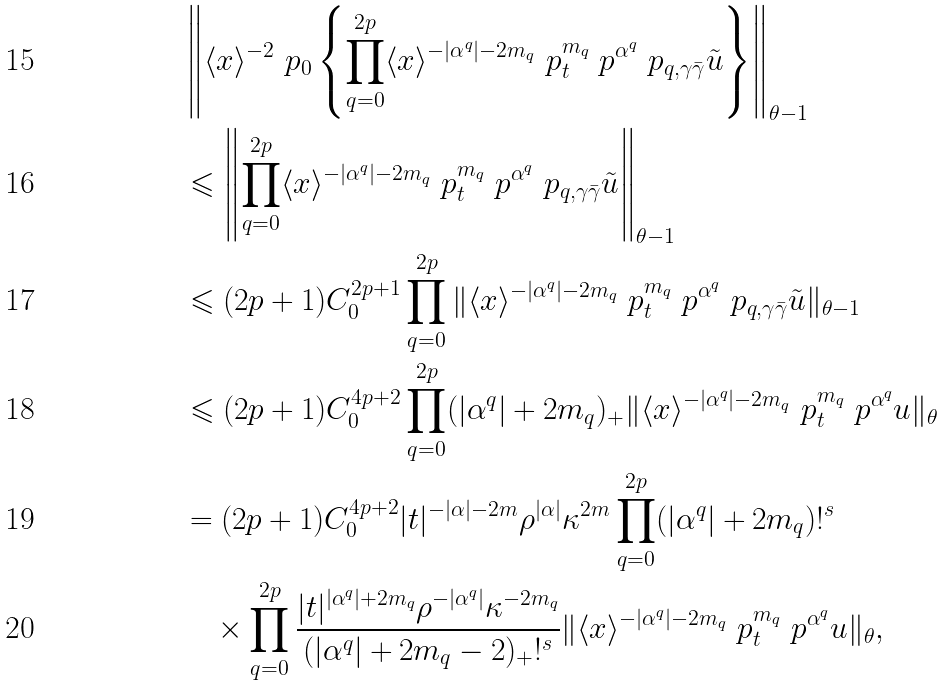Convert formula to latex. <formula><loc_0><loc_0><loc_500><loc_500>& \left \| \langle { x } \rangle ^ { - 2 } \ p _ { 0 } \left \{ \prod _ { q = 0 } ^ { 2 p } \langle { x } \rangle ^ { - | \alpha ^ { q } | - 2 m _ { q } } \ p _ { t } ^ { m _ { q } } \ p ^ { \alpha ^ { q } } \ p _ { q , \gamma \bar { \gamma } } \tilde { u } \right \} \right \| _ { \theta - 1 } \\ & \leqslant \left \| \prod _ { q = 0 } ^ { 2 p } \langle { x } \rangle ^ { - | \alpha ^ { q } | - 2 m _ { q } } \ p _ { t } ^ { m _ { q } } \ p ^ { \alpha ^ { q } } \ p _ { q , \gamma \bar { \gamma } } \tilde { u } \right \| _ { \theta - 1 } \\ & \leqslant ( 2 p + 1 ) C _ { 0 } ^ { 2 p + 1 } \prod _ { q = 0 } ^ { 2 p } \| \langle { x } \rangle ^ { - | \alpha ^ { q } | - 2 m _ { q } } \ p _ { t } ^ { m _ { q } } \ p ^ { \alpha ^ { q } } \ p _ { q , \gamma \bar { \gamma } } \tilde { u } \| _ { \theta - 1 } \\ & \leqslant ( 2 p + 1 ) C _ { 0 } ^ { 4 p + 2 } \prod _ { q = 0 } ^ { 2 p } ( | \alpha ^ { q } | + 2 m _ { q } ) _ { + } \| \langle { x } \rangle ^ { - | \alpha ^ { q } | - 2 m _ { q } } \ p _ { t } ^ { m _ { q } } \ p ^ { \alpha ^ { q } } u \| _ { \theta } \\ & = ( 2 p + 1 ) C _ { 0 } ^ { 4 p + 2 } | { t } | ^ { - | \alpha | - 2 m } \rho ^ { | \alpha | } \kappa ^ { 2 m } \prod _ { q = 0 } ^ { 2 p } ( | \alpha ^ { q } | + 2 m _ { q } ) ! ^ { s } \\ & \quad \times \prod _ { q = 0 } ^ { 2 p } \frac { | { t } | ^ { | \alpha ^ { q } | + 2 m _ { q } } \rho ^ { - | \alpha ^ { q } | } \kappa ^ { - 2 m _ { q } } } { ( | \alpha ^ { q } | + 2 m _ { q } - 2 ) _ { + } ! ^ { s } } \| \langle { x } \rangle ^ { - | \alpha ^ { q } | - 2 m _ { q } } \ p _ { t } ^ { m _ { q } } \ p ^ { \alpha ^ { q } } u \| _ { \theta } ,</formula> 